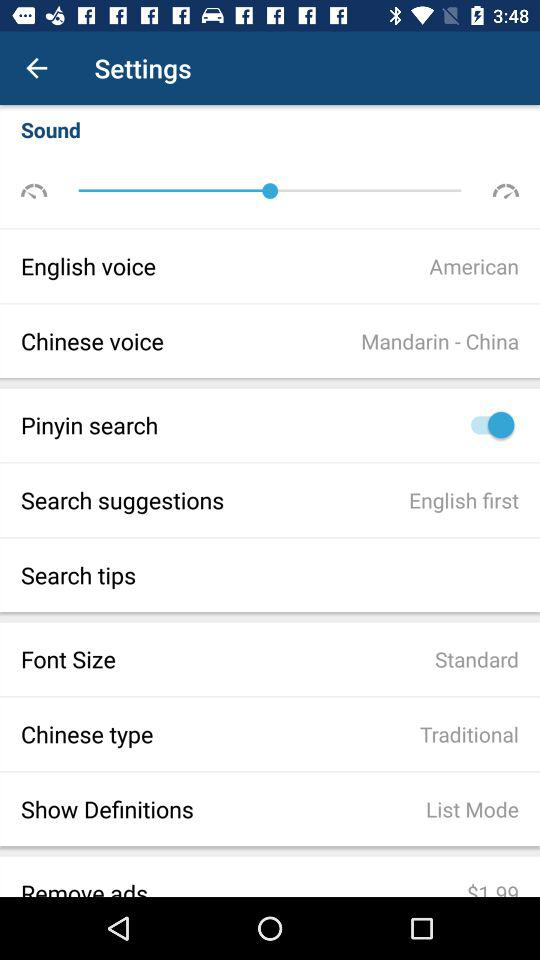What is the type of "English voice"? The type of "English voice" is American. 